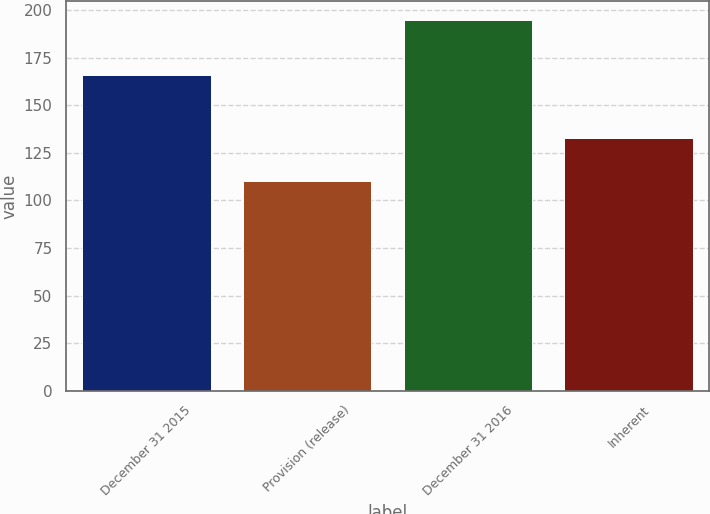Convert chart. <chart><loc_0><loc_0><loc_500><loc_500><bar_chart><fcel>December 31 2015<fcel>Provision (release)<fcel>December 31 2016<fcel>Inherent<nl><fcel>166<fcel>110<fcel>195<fcel>133<nl></chart> 